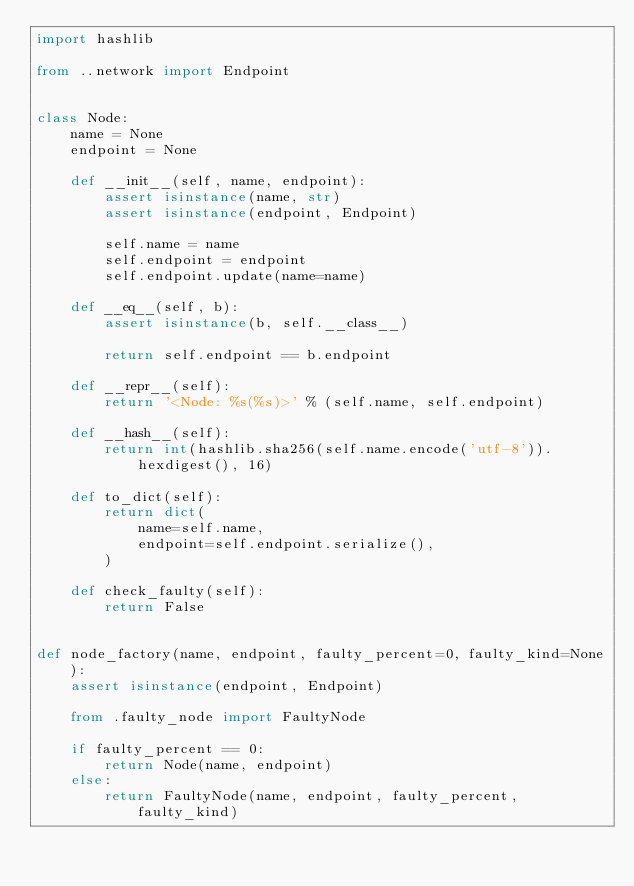Convert code to text. <code><loc_0><loc_0><loc_500><loc_500><_Python_>import hashlib

from ..network import Endpoint


class Node:
    name = None
    endpoint = None

    def __init__(self, name, endpoint):
        assert isinstance(name, str)
        assert isinstance(endpoint, Endpoint)

        self.name = name
        self.endpoint = endpoint
        self.endpoint.update(name=name)

    def __eq__(self, b):
        assert isinstance(b, self.__class__)

        return self.endpoint == b.endpoint

    def __repr__(self):
        return '<Node: %s(%s)>' % (self.name, self.endpoint)

    def __hash__(self):
        return int(hashlib.sha256(self.name.encode('utf-8')).hexdigest(), 16)

    def to_dict(self):
        return dict(
            name=self.name,
            endpoint=self.endpoint.serialize(),
        )

    def check_faulty(self):
        return False


def node_factory(name, endpoint, faulty_percent=0, faulty_kind=None):
    assert isinstance(endpoint, Endpoint)

    from .faulty_node import FaultyNode

    if faulty_percent == 0:
        return Node(name, endpoint)
    else:
        return FaultyNode(name, endpoint, faulty_percent, faulty_kind)
</code> 